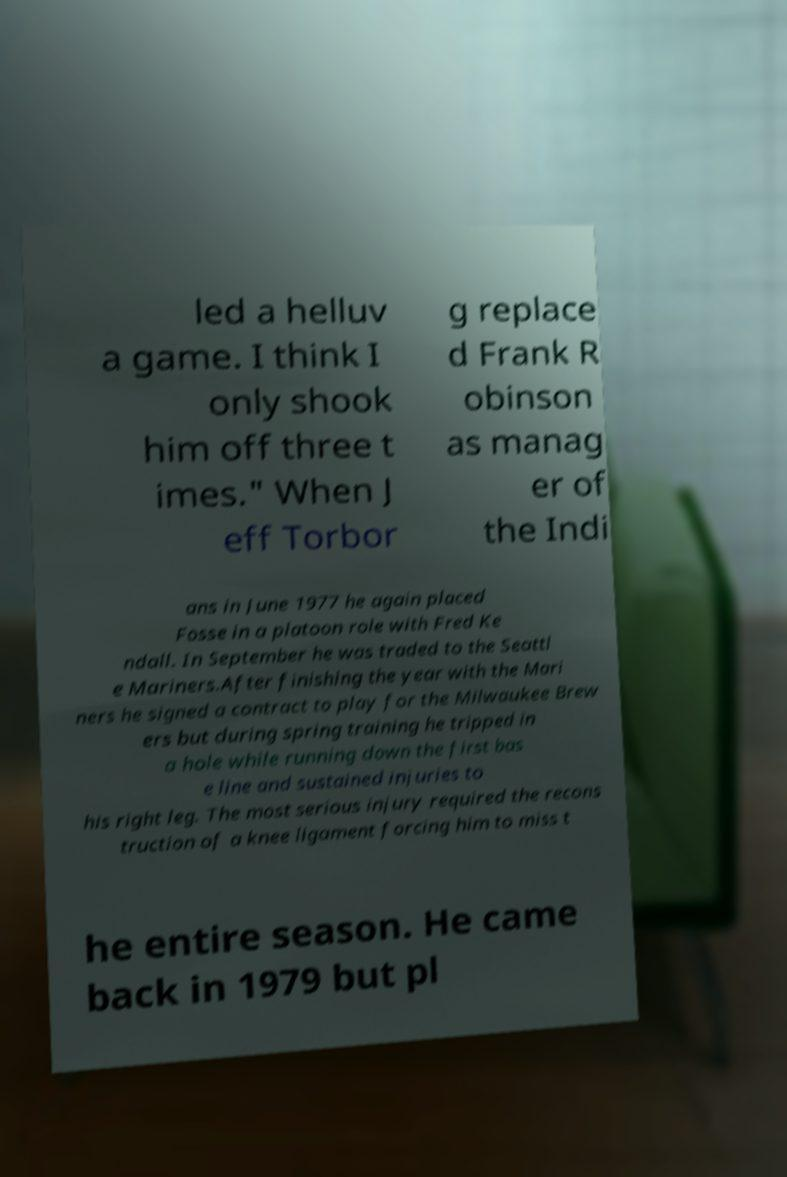Please read and relay the text visible in this image. What does it say? led a helluv a game. I think I only shook him off three t imes." When J eff Torbor g replace d Frank R obinson as manag er of the Indi ans in June 1977 he again placed Fosse in a platoon role with Fred Ke ndall. In September he was traded to the Seattl e Mariners.After finishing the year with the Mari ners he signed a contract to play for the Milwaukee Brew ers but during spring training he tripped in a hole while running down the first bas e line and sustained injuries to his right leg. The most serious injury required the recons truction of a knee ligament forcing him to miss t he entire season. He came back in 1979 but pl 